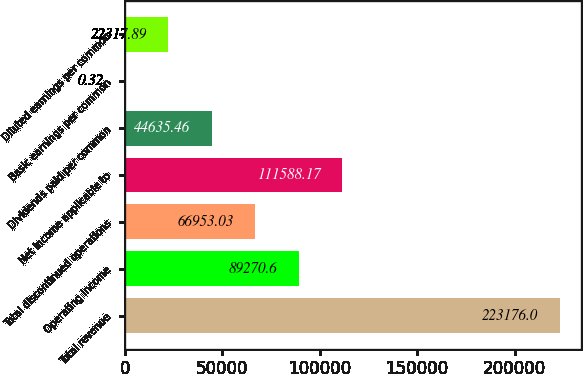<chart> <loc_0><loc_0><loc_500><loc_500><bar_chart><fcel>Total revenue<fcel>Operating income<fcel>Total discontinued operations<fcel>Net income applicable to<fcel>Dividends paid per common<fcel>Basic earnings per common<fcel>Diluted earnings per common<nl><fcel>223176<fcel>89270.6<fcel>66953<fcel>111588<fcel>44635.5<fcel>0.32<fcel>22317.9<nl></chart> 